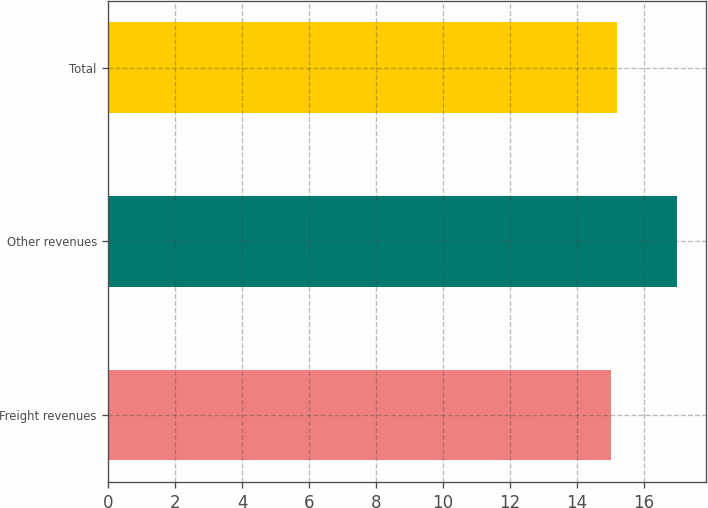Convert chart to OTSL. <chart><loc_0><loc_0><loc_500><loc_500><bar_chart><fcel>Freight revenues<fcel>Other revenues<fcel>Total<nl><fcel>15<fcel>17<fcel>15.2<nl></chart> 